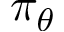Convert formula to latex. <formula><loc_0><loc_0><loc_500><loc_500>\pi _ { \theta }</formula> 